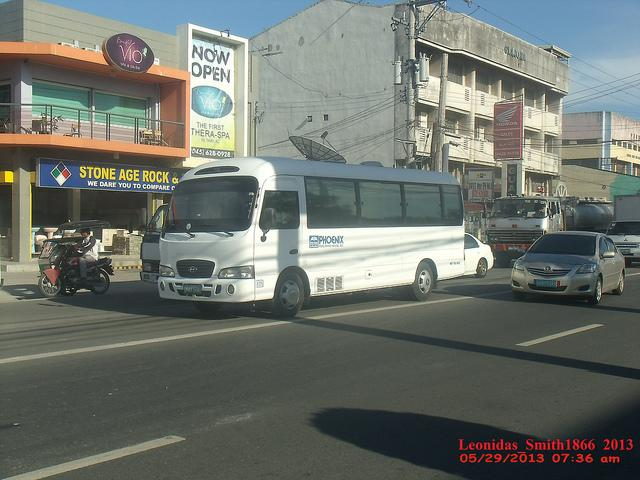What type of vehicle is sold in the building to the rear of the bus? Please explain your reasoning. motorcycles. There are bikes by the bus. 